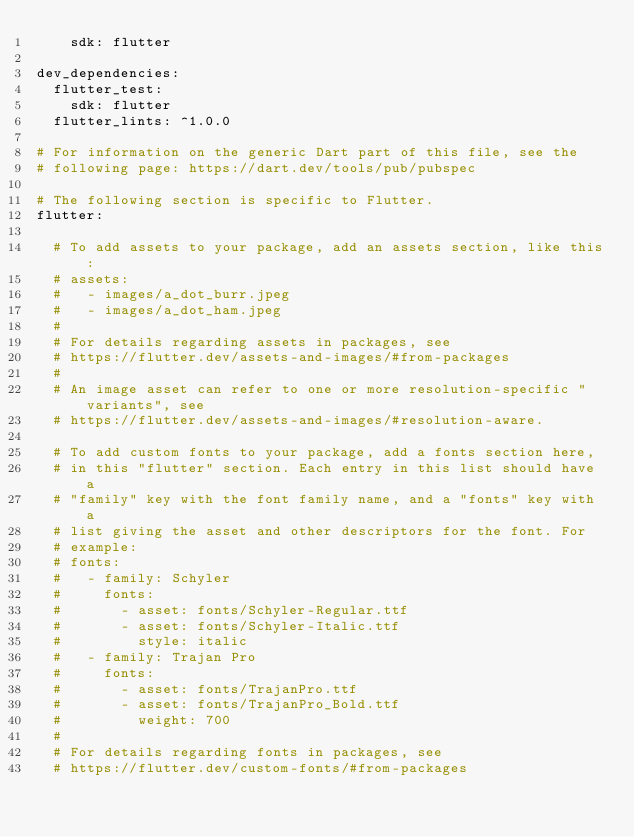Convert code to text. <code><loc_0><loc_0><loc_500><loc_500><_YAML_>    sdk: flutter

dev_dependencies:
  flutter_test:
    sdk: flutter
  flutter_lints: ^1.0.0

# For information on the generic Dart part of this file, see the
# following page: https://dart.dev/tools/pub/pubspec

# The following section is specific to Flutter.
flutter:

  # To add assets to your package, add an assets section, like this:
  # assets:
  #   - images/a_dot_burr.jpeg
  #   - images/a_dot_ham.jpeg
  #
  # For details regarding assets in packages, see
  # https://flutter.dev/assets-and-images/#from-packages
  #
  # An image asset can refer to one or more resolution-specific "variants", see
  # https://flutter.dev/assets-and-images/#resolution-aware.

  # To add custom fonts to your package, add a fonts section here,
  # in this "flutter" section. Each entry in this list should have a
  # "family" key with the font family name, and a "fonts" key with a
  # list giving the asset and other descriptors for the font. For
  # example:
  # fonts:
  #   - family: Schyler
  #     fonts:
  #       - asset: fonts/Schyler-Regular.ttf
  #       - asset: fonts/Schyler-Italic.ttf
  #         style: italic
  #   - family: Trajan Pro
  #     fonts:
  #       - asset: fonts/TrajanPro.ttf
  #       - asset: fonts/TrajanPro_Bold.ttf
  #         weight: 700
  #
  # For details regarding fonts in packages, see
  # https://flutter.dev/custom-fonts/#from-packages
</code> 